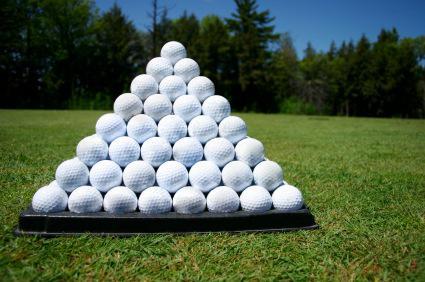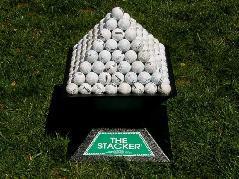The first image is the image on the left, the second image is the image on the right. Evaluate the accuracy of this statement regarding the images: "One of the images contain a golf ball right next to a golf club.". Is it true? Answer yes or no. No. The first image is the image on the left, the second image is the image on the right. For the images shown, is this caption "An image shows a club right next to a golf ball." true? Answer yes or no. No. 